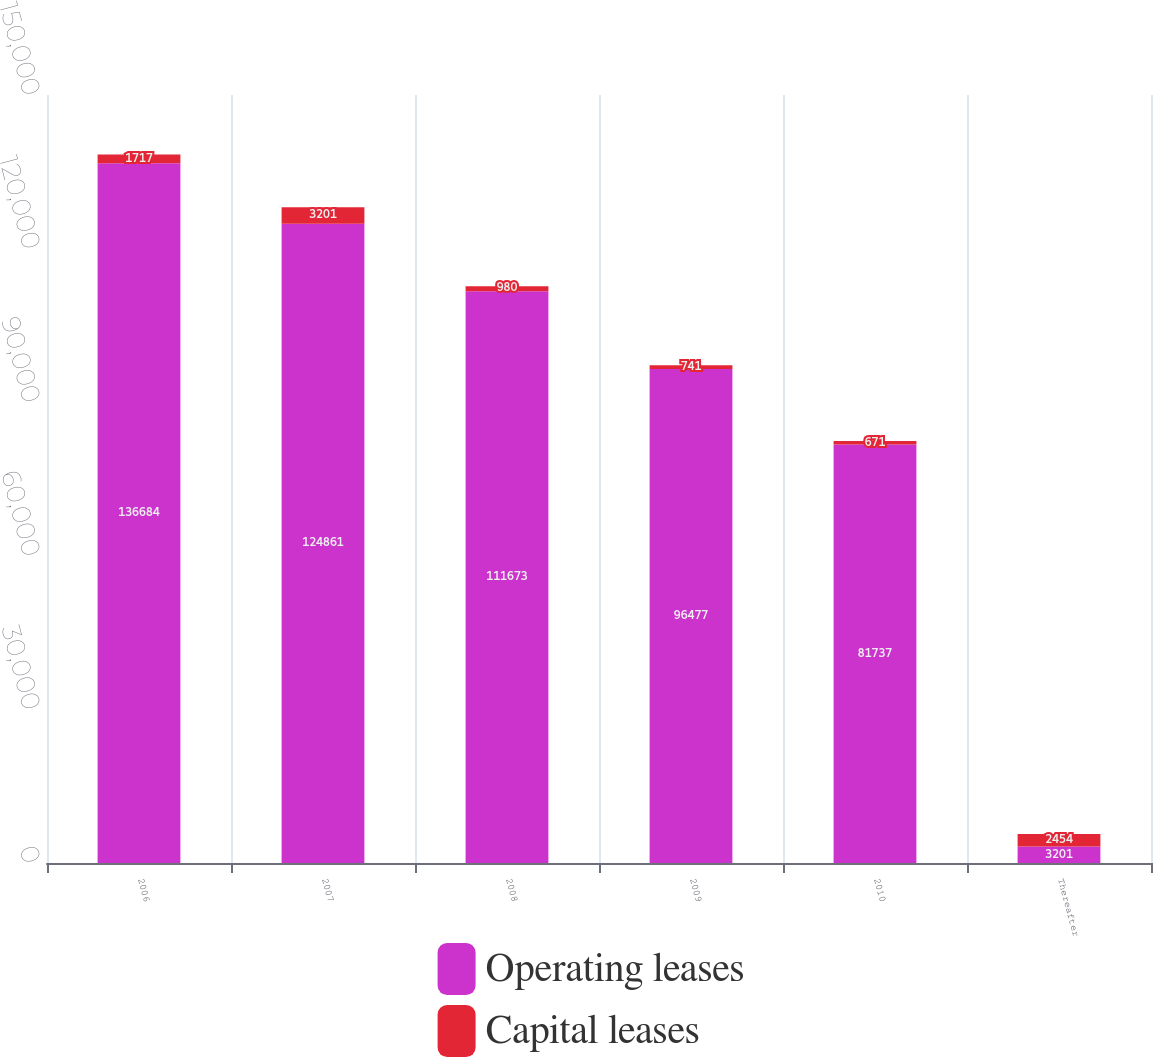<chart> <loc_0><loc_0><loc_500><loc_500><stacked_bar_chart><ecel><fcel>2006<fcel>2007<fcel>2008<fcel>2009<fcel>2010<fcel>Thereafter<nl><fcel>Operating leases<fcel>136684<fcel>124861<fcel>111673<fcel>96477<fcel>81737<fcel>3201<nl><fcel>Capital leases<fcel>1717<fcel>3201<fcel>980<fcel>741<fcel>671<fcel>2454<nl></chart> 